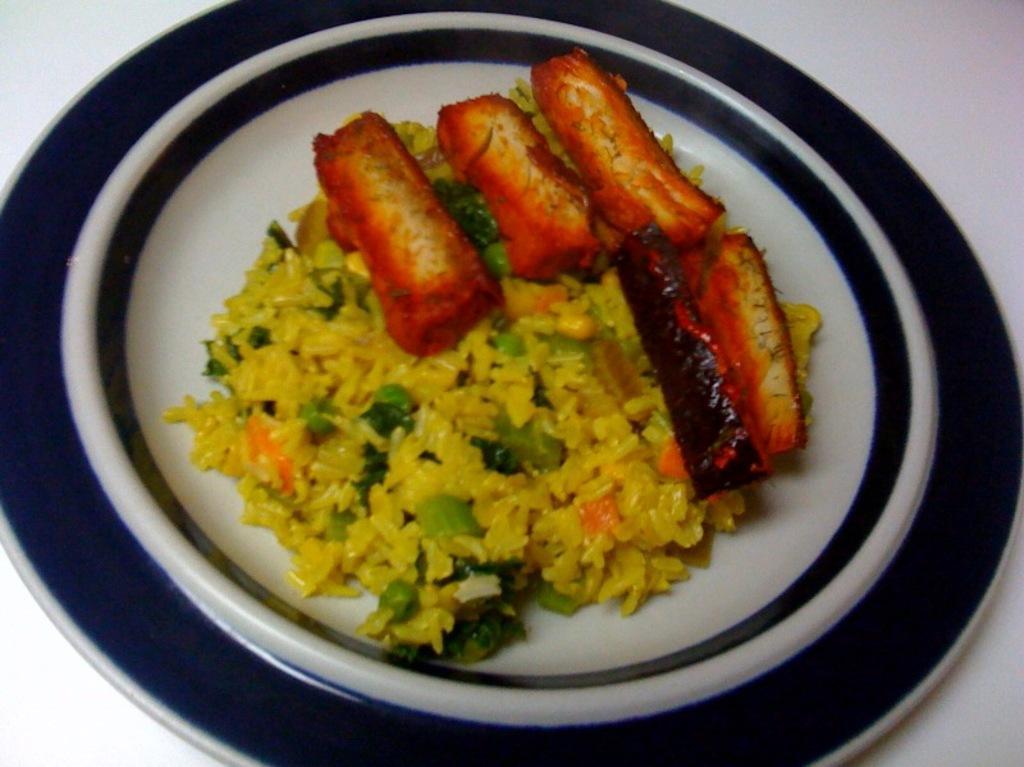Describe this image in one or two sentences. In this image we can see food items in the plate on a platform. 